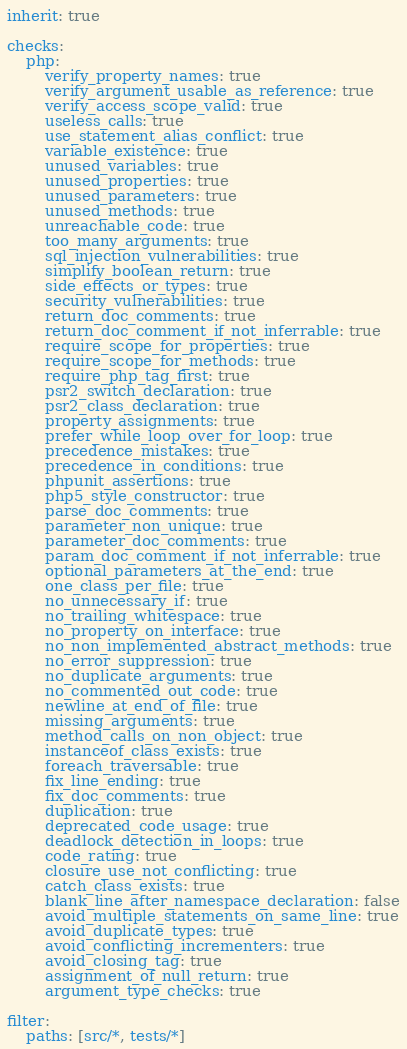Convert code to text. <code><loc_0><loc_0><loc_500><loc_500><_YAML_>inherit: true

checks:
    php:
        verify_property_names: true
        verify_argument_usable_as_reference: true
        verify_access_scope_valid: true
        useless_calls: true
        use_statement_alias_conflict: true
        variable_existence: true
        unused_variables: true
        unused_properties: true
        unused_parameters: true
        unused_methods: true
        unreachable_code: true
        too_many_arguments: true
        sql_injection_vulnerabilities: true
        simplify_boolean_return: true
        side_effects_or_types: true
        security_vulnerabilities: true
        return_doc_comments: true
        return_doc_comment_if_not_inferrable: true
        require_scope_for_properties: true
        require_scope_for_methods: true
        require_php_tag_first: true
        psr2_switch_declaration: true
        psr2_class_declaration: true
        property_assignments: true
        prefer_while_loop_over_for_loop: true
        precedence_mistakes: true
        precedence_in_conditions: true
        phpunit_assertions: true
        php5_style_constructor: true
        parse_doc_comments: true
        parameter_non_unique: true
        parameter_doc_comments: true
        param_doc_comment_if_not_inferrable: true
        optional_parameters_at_the_end: true
        one_class_per_file: true
        no_unnecessary_if: true
        no_trailing_whitespace: true
        no_property_on_interface: true
        no_non_implemented_abstract_methods: true
        no_error_suppression: true
        no_duplicate_arguments: true
        no_commented_out_code: true
        newline_at_end_of_file: true
        missing_arguments: true
        method_calls_on_non_object: true
        instanceof_class_exists: true
        foreach_traversable: true
        fix_line_ending: true
        fix_doc_comments: true
        duplication: true
        deprecated_code_usage: true
        deadlock_detection_in_loops: true
        code_rating: true
        closure_use_not_conflicting: true
        catch_class_exists: true
        blank_line_after_namespace_declaration: false
        avoid_multiple_statements_on_same_line: true
        avoid_duplicate_types: true
        avoid_conflicting_incrementers: true
        avoid_closing_tag: true
        assignment_of_null_return: true
        argument_type_checks: true

filter:
    paths: [src/*, tests/*]
</code> 